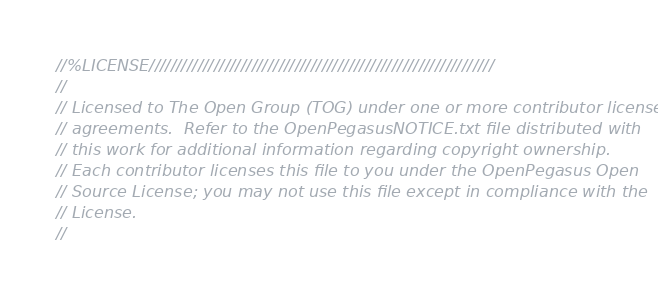<code> <loc_0><loc_0><loc_500><loc_500><_C++_>//%LICENSE////////////////////////////////////////////////////////////////
//
// Licensed to The Open Group (TOG) under one or more contributor license
// agreements.  Refer to the OpenPegasusNOTICE.txt file distributed with
// this work for additional information regarding copyright ownership.
// Each contributor licenses this file to you under the OpenPegasus Open
// Source License; you may not use this file except in compliance with the
// License.
//</code> 